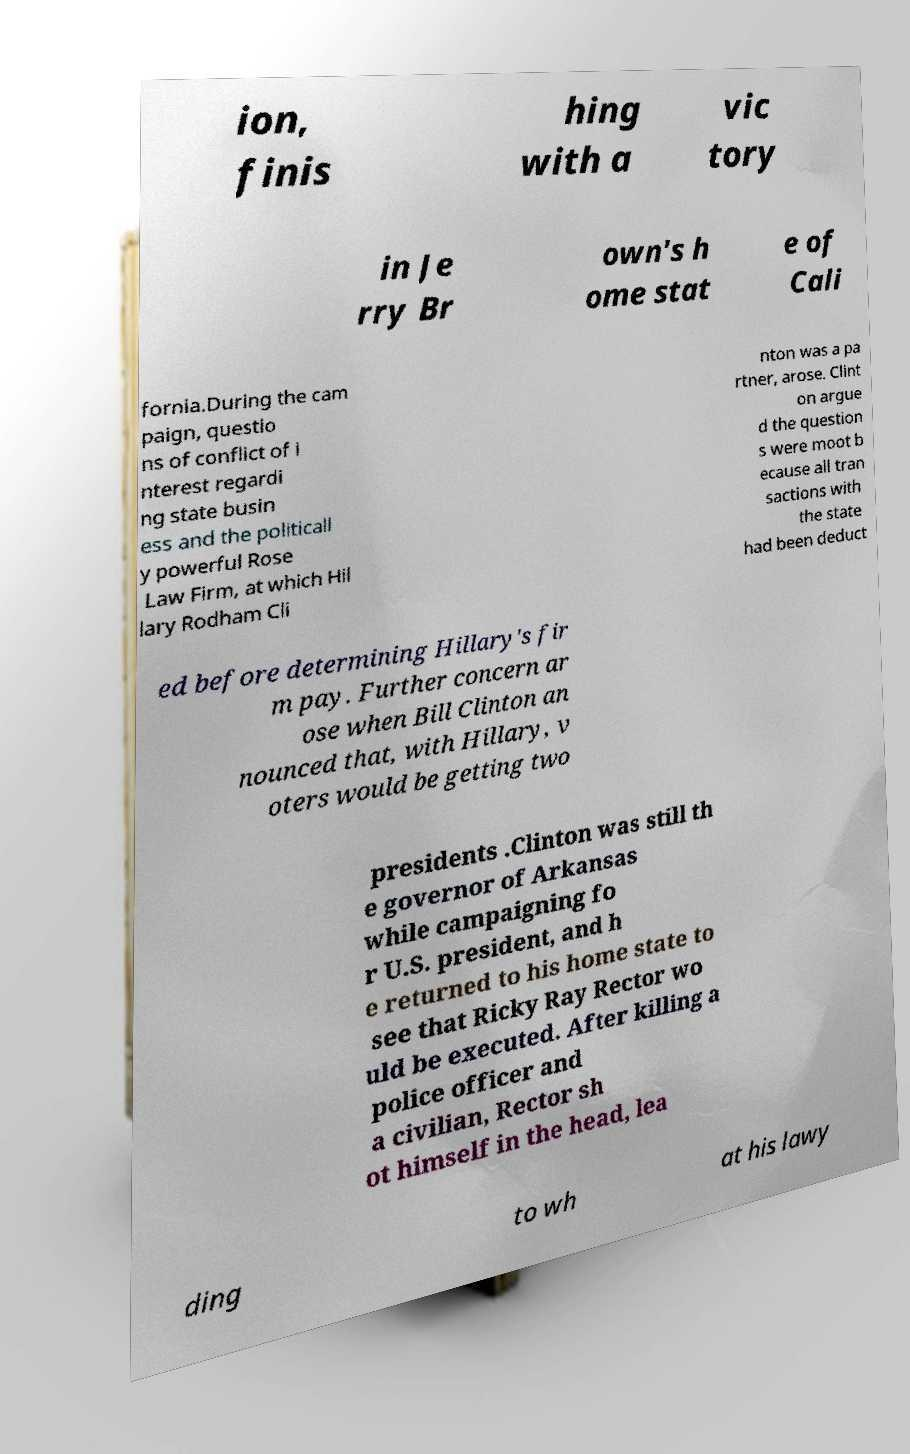For documentation purposes, I need the text within this image transcribed. Could you provide that? ion, finis hing with a vic tory in Je rry Br own's h ome stat e of Cali fornia.During the cam paign, questio ns of conflict of i nterest regardi ng state busin ess and the politicall y powerful Rose Law Firm, at which Hil lary Rodham Cli nton was a pa rtner, arose. Clint on argue d the question s were moot b ecause all tran sactions with the state had been deduct ed before determining Hillary's fir m pay. Further concern ar ose when Bill Clinton an nounced that, with Hillary, v oters would be getting two presidents .Clinton was still th e governor of Arkansas while campaigning fo r U.S. president, and h e returned to his home state to see that Ricky Ray Rector wo uld be executed. After killing a police officer and a civilian, Rector sh ot himself in the head, lea ding to wh at his lawy 